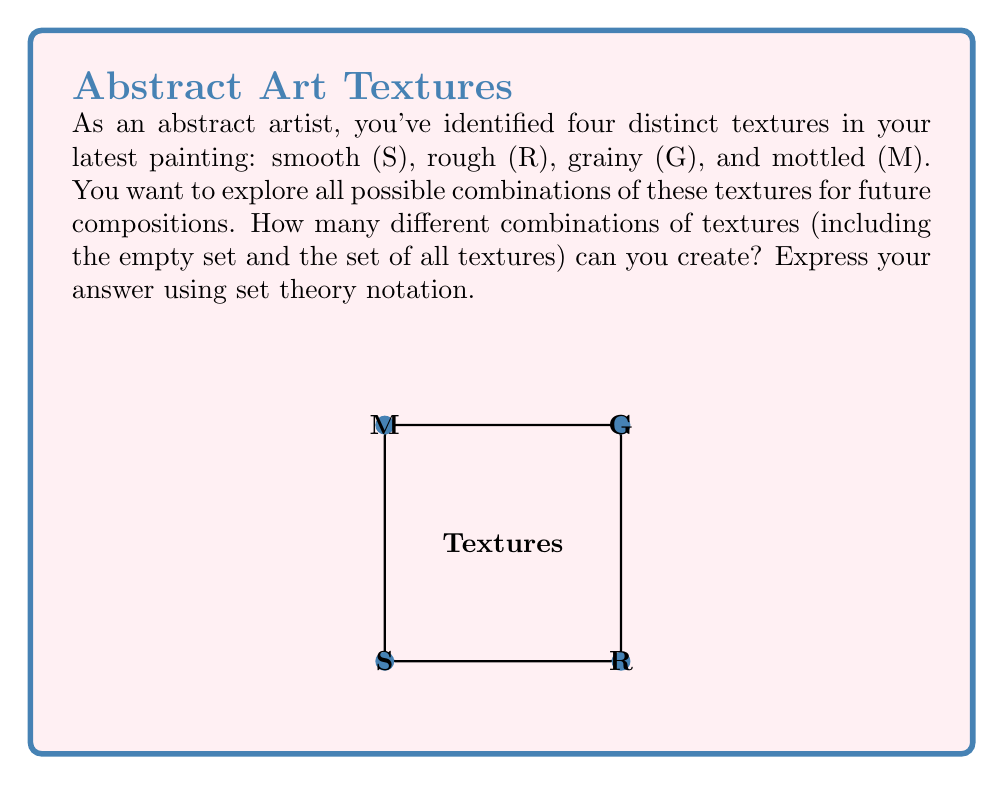Give your solution to this math problem. Let's approach this step-by-step:

1) First, we need to understand what we're looking for. We want to find the number of elements in the power set of the set of textures.

2) The set of textures is $T = \{S, R, G, M\}$. This set has 4 elements.

3) The power set of a set $A$, denoted as $P(A)$, is the set of all subsets of $A$, including the empty set and $A$ itself.

4) For a set with $n$ elements, the number of elements in its power set is given by $2^n$.

5) In this case, $n = 4$, so the number of elements in the power set will be $2^4 = 16$.

6) We can verify this by listing out all possible subsets:
   - Empty set: $\{\}$
   - Single element sets: $\{S\}, \{R\}, \{G\}, \{M\}$
   - Two element sets: $\{S,R\}, \{S,G\}, \{S,M\}, \{R,G\}, \{R,M\}, \{G,M\}$
   - Three element sets: $\{S,R,G\}, \{S,R,M\}, \{S,G,M\}, \{R,G,M\}$
   - Full set: $\{S,R,G,M\}$

7) In set theory notation, we express this as $|P(T)| = 2^4 = 16$, where $|P(T)|$ denotes the cardinality (number of elements) of the power set of $T$.
Answer: $|P(T)| = 16$ 